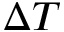<formula> <loc_0><loc_0><loc_500><loc_500>\Delta T</formula> 